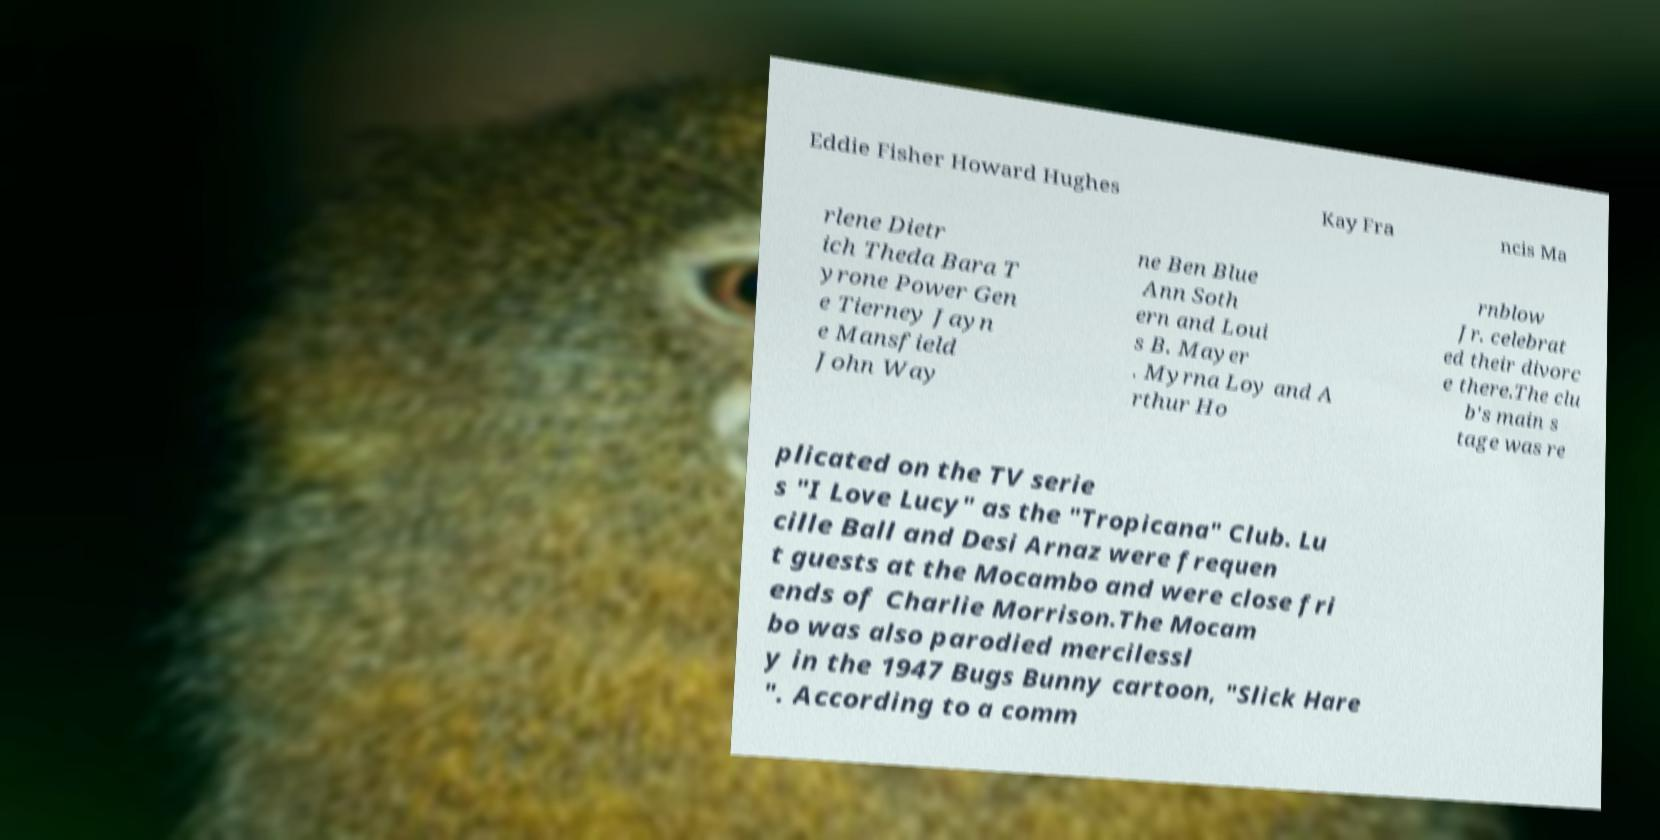Can you accurately transcribe the text from the provided image for me? Eddie Fisher Howard Hughes Kay Fra ncis Ma rlene Dietr ich Theda Bara T yrone Power Gen e Tierney Jayn e Mansfield John Way ne Ben Blue Ann Soth ern and Loui s B. Mayer . Myrna Loy and A rthur Ho rnblow Jr. celebrat ed their divorc e there.The clu b's main s tage was re plicated on the TV serie s "I Love Lucy" as the "Tropicana" Club. Lu cille Ball and Desi Arnaz were frequen t guests at the Mocambo and were close fri ends of Charlie Morrison.The Mocam bo was also parodied mercilessl y in the 1947 Bugs Bunny cartoon, "Slick Hare ". According to a comm 